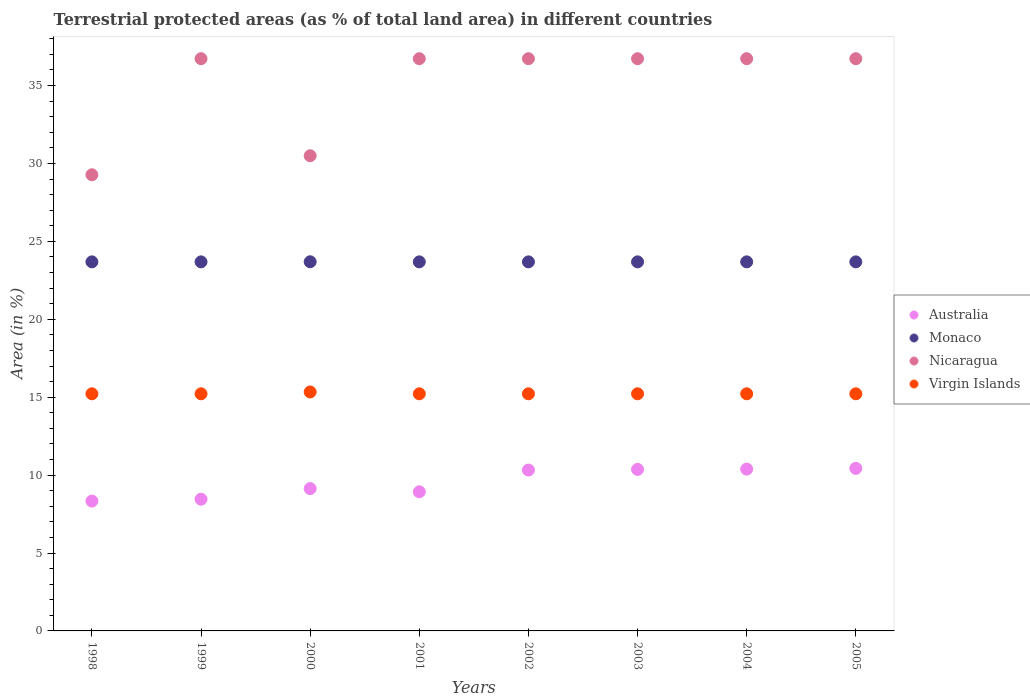Is the number of dotlines equal to the number of legend labels?
Ensure brevity in your answer.  Yes. What is the percentage of terrestrial protected land in Nicaragua in 2002?
Provide a short and direct response. 36.72. Across all years, what is the maximum percentage of terrestrial protected land in Monaco?
Your answer should be compact. 23.69. Across all years, what is the minimum percentage of terrestrial protected land in Monaco?
Give a very brief answer. 23.68. In which year was the percentage of terrestrial protected land in Australia maximum?
Your response must be concise. 2005. In which year was the percentage of terrestrial protected land in Australia minimum?
Make the answer very short. 1998. What is the total percentage of terrestrial protected land in Virgin Islands in the graph?
Ensure brevity in your answer.  121.86. What is the difference between the percentage of terrestrial protected land in Nicaragua in 1999 and the percentage of terrestrial protected land in Australia in 2000?
Your answer should be very brief. 27.59. What is the average percentage of terrestrial protected land in Monaco per year?
Make the answer very short. 23.69. In the year 1999, what is the difference between the percentage of terrestrial protected land in Australia and percentage of terrestrial protected land in Monaco?
Offer a terse response. -15.23. Is the difference between the percentage of terrestrial protected land in Australia in 2000 and 2003 greater than the difference between the percentage of terrestrial protected land in Monaco in 2000 and 2003?
Make the answer very short. No. What is the difference between the highest and the second highest percentage of terrestrial protected land in Monaco?
Your response must be concise. 0.01. What is the difference between the highest and the lowest percentage of terrestrial protected land in Virgin Islands?
Offer a terse response. 0.12. Is the sum of the percentage of terrestrial protected land in Nicaragua in 2002 and 2005 greater than the maximum percentage of terrestrial protected land in Monaco across all years?
Keep it short and to the point. Yes. Is it the case that in every year, the sum of the percentage of terrestrial protected land in Monaco and percentage of terrestrial protected land in Nicaragua  is greater than the percentage of terrestrial protected land in Australia?
Offer a very short reply. Yes. Is the percentage of terrestrial protected land in Monaco strictly greater than the percentage of terrestrial protected land in Virgin Islands over the years?
Make the answer very short. Yes. How many dotlines are there?
Provide a succinct answer. 4. How many years are there in the graph?
Provide a short and direct response. 8. What is the difference between two consecutive major ticks on the Y-axis?
Your answer should be compact. 5. Are the values on the major ticks of Y-axis written in scientific E-notation?
Your response must be concise. No. Does the graph contain any zero values?
Offer a very short reply. No. Where does the legend appear in the graph?
Give a very brief answer. Center right. How many legend labels are there?
Ensure brevity in your answer.  4. How are the legend labels stacked?
Ensure brevity in your answer.  Vertical. What is the title of the graph?
Provide a succinct answer. Terrestrial protected areas (as % of total land area) in different countries. Does "Congo (Republic)" appear as one of the legend labels in the graph?
Ensure brevity in your answer.  No. What is the label or title of the X-axis?
Provide a succinct answer. Years. What is the label or title of the Y-axis?
Offer a very short reply. Area (in %). What is the Area (in %) of Australia in 1998?
Keep it short and to the point. 8.33. What is the Area (in %) of Monaco in 1998?
Provide a succinct answer. 23.68. What is the Area (in %) in Nicaragua in 1998?
Your response must be concise. 29.27. What is the Area (in %) of Virgin Islands in 1998?
Provide a succinct answer. 15.22. What is the Area (in %) in Australia in 1999?
Ensure brevity in your answer.  8.45. What is the Area (in %) in Monaco in 1999?
Give a very brief answer. 23.68. What is the Area (in %) of Nicaragua in 1999?
Provide a succinct answer. 36.72. What is the Area (in %) of Virgin Islands in 1999?
Provide a short and direct response. 15.22. What is the Area (in %) in Australia in 2000?
Offer a terse response. 9.13. What is the Area (in %) in Monaco in 2000?
Provide a succinct answer. 23.69. What is the Area (in %) of Nicaragua in 2000?
Keep it short and to the point. 30.49. What is the Area (in %) of Virgin Islands in 2000?
Make the answer very short. 15.34. What is the Area (in %) of Australia in 2001?
Your answer should be compact. 8.93. What is the Area (in %) of Monaco in 2001?
Give a very brief answer. 23.68. What is the Area (in %) of Nicaragua in 2001?
Keep it short and to the point. 36.72. What is the Area (in %) of Virgin Islands in 2001?
Ensure brevity in your answer.  15.22. What is the Area (in %) of Australia in 2002?
Provide a succinct answer. 10.32. What is the Area (in %) of Monaco in 2002?
Provide a short and direct response. 23.68. What is the Area (in %) of Nicaragua in 2002?
Offer a terse response. 36.72. What is the Area (in %) of Virgin Islands in 2002?
Your response must be concise. 15.22. What is the Area (in %) of Australia in 2003?
Offer a terse response. 10.37. What is the Area (in %) in Monaco in 2003?
Make the answer very short. 23.68. What is the Area (in %) of Nicaragua in 2003?
Provide a short and direct response. 36.72. What is the Area (in %) in Virgin Islands in 2003?
Offer a terse response. 15.22. What is the Area (in %) of Australia in 2004?
Make the answer very short. 10.39. What is the Area (in %) in Monaco in 2004?
Offer a terse response. 23.68. What is the Area (in %) of Nicaragua in 2004?
Offer a very short reply. 36.72. What is the Area (in %) of Virgin Islands in 2004?
Offer a very short reply. 15.22. What is the Area (in %) of Australia in 2005?
Offer a very short reply. 10.43. What is the Area (in %) in Monaco in 2005?
Offer a very short reply. 23.68. What is the Area (in %) in Nicaragua in 2005?
Offer a very short reply. 36.72. What is the Area (in %) of Virgin Islands in 2005?
Provide a succinct answer. 15.22. Across all years, what is the maximum Area (in %) of Australia?
Ensure brevity in your answer.  10.43. Across all years, what is the maximum Area (in %) of Monaco?
Your response must be concise. 23.69. Across all years, what is the maximum Area (in %) of Nicaragua?
Offer a very short reply. 36.72. Across all years, what is the maximum Area (in %) of Virgin Islands?
Make the answer very short. 15.34. Across all years, what is the minimum Area (in %) in Australia?
Give a very brief answer. 8.33. Across all years, what is the minimum Area (in %) of Monaco?
Provide a short and direct response. 23.68. Across all years, what is the minimum Area (in %) of Nicaragua?
Make the answer very short. 29.27. Across all years, what is the minimum Area (in %) in Virgin Islands?
Your answer should be compact. 15.22. What is the total Area (in %) of Australia in the graph?
Offer a very short reply. 76.36. What is the total Area (in %) of Monaco in the graph?
Your answer should be very brief. 189.48. What is the total Area (in %) of Nicaragua in the graph?
Make the answer very short. 280.11. What is the total Area (in %) in Virgin Islands in the graph?
Your response must be concise. 121.86. What is the difference between the Area (in %) of Australia in 1998 and that in 1999?
Give a very brief answer. -0.12. What is the difference between the Area (in %) of Nicaragua in 1998 and that in 1999?
Provide a short and direct response. -7.45. What is the difference between the Area (in %) in Australia in 1998 and that in 2000?
Give a very brief answer. -0.8. What is the difference between the Area (in %) of Monaco in 1998 and that in 2000?
Provide a succinct answer. -0.01. What is the difference between the Area (in %) in Nicaragua in 1998 and that in 2000?
Your answer should be very brief. -1.22. What is the difference between the Area (in %) of Virgin Islands in 1998 and that in 2000?
Ensure brevity in your answer.  -0.12. What is the difference between the Area (in %) of Australia in 1998 and that in 2001?
Provide a succinct answer. -0.59. What is the difference between the Area (in %) of Nicaragua in 1998 and that in 2001?
Your answer should be compact. -7.45. What is the difference between the Area (in %) of Virgin Islands in 1998 and that in 2001?
Your answer should be compact. 0. What is the difference between the Area (in %) in Australia in 1998 and that in 2002?
Your answer should be very brief. -1.99. What is the difference between the Area (in %) of Nicaragua in 1998 and that in 2002?
Provide a succinct answer. -7.45. What is the difference between the Area (in %) of Australia in 1998 and that in 2003?
Offer a terse response. -2.03. What is the difference between the Area (in %) of Monaco in 1998 and that in 2003?
Provide a short and direct response. 0. What is the difference between the Area (in %) in Nicaragua in 1998 and that in 2003?
Keep it short and to the point. -7.45. What is the difference between the Area (in %) in Australia in 1998 and that in 2004?
Provide a short and direct response. -2.05. What is the difference between the Area (in %) of Nicaragua in 1998 and that in 2004?
Offer a terse response. -7.45. What is the difference between the Area (in %) in Australia in 1998 and that in 2005?
Offer a terse response. -2.1. What is the difference between the Area (in %) in Monaco in 1998 and that in 2005?
Your answer should be very brief. 0. What is the difference between the Area (in %) of Nicaragua in 1998 and that in 2005?
Offer a very short reply. -7.45. What is the difference between the Area (in %) in Australia in 1999 and that in 2000?
Give a very brief answer. -0.68. What is the difference between the Area (in %) of Monaco in 1999 and that in 2000?
Provide a succinct answer. -0.01. What is the difference between the Area (in %) of Nicaragua in 1999 and that in 2000?
Your answer should be compact. 6.23. What is the difference between the Area (in %) of Virgin Islands in 1999 and that in 2000?
Your answer should be very brief. -0.12. What is the difference between the Area (in %) in Australia in 1999 and that in 2001?
Your answer should be very brief. -0.48. What is the difference between the Area (in %) in Monaco in 1999 and that in 2001?
Make the answer very short. 0. What is the difference between the Area (in %) in Nicaragua in 1999 and that in 2001?
Offer a very short reply. 0. What is the difference between the Area (in %) in Australia in 1999 and that in 2002?
Give a very brief answer. -1.87. What is the difference between the Area (in %) in Monaco in 1999 and that in 2002?
Your answer should be compact. 0. What is the difference between the Area (in %) of Virgin Islands in 1999 and that in 2002?
Make the answer very short. 0. What is the difference between the Area (in %) of Australia in 1999 and that in 2003?
Your response must be concise. -1.91. What is the difference between the Area (in %) of Virgin Islands in 1999 and that in 2003?
Make the answer very short. 0. What is the difference between the Area (in %) of Australia in 1999 and that in 2004?
Ensure brevity in your answer.  -1.93. What is the difference between the Area (in %) of Nicaragua in 1999 and that in 2004?
Your response must be concise. 0. What is the difference between the Area (in %) of Australia in 1999 and that in 2005?
Provide a short and direct response. -1.98. What is the difference between the Area (in %) in Monaco in 1999 and that in 2005?
Your answer should be compact. 0. What is the difference between the Area (in %) in Virgin Islands in 1999 and that in 2005?
Your response must be concise. 0. What is the difference between the Area (in %) in Australia in 2000 and that in 2001?
Offer a terse response. 0.21. What is the difference between the Area (in %) of Monaco in 2000 and that in 2001?
Provide a succinct answer. 0.01. What is the difference between the Area (in %) in Nicaragua in 2000 and that in 2001?
Provide a short and direct response. -6.23. What is the difference between the Area (in %) in Virgin Islands in 2000 and that in 2001?
Keep it short and to the point. 0.12. What is the difference between the Area (in %) of Australia in 2000 and that in 2002?
Keep it short and to the point. -1.19. What is the difference between the Area (in %) in Monaco in 2000 and that in 2002?
Your answer should be very brief. 0.01. What is the difference between the Area (in %) in Nicaragua in 2000 and that in 2002?
Keep it short and to the point. -6.23. What is the difference between the Area (in %) of Virgin Islands in 2000 and that in 2002?
Provide a succinct answer. 0.12. What is the difference between the Area (in %) in Australia in 2000 and that in 2003?
Your answer should be compact. -1.23. What is the difference between the Area (in %) of Monaco in 2000 and that in 2003?
Provide a short and direct response. 0.01. What is the difference between the Area (in %) in Nicaragua in 2000 and that in 2003?
Give a very brief answer. -6.23. What is the difference between the Area (in %) of Virgin Islands in 2000 and that in 2003?
Give a very brief answer. 0.12. What is the difference between the Area (in %) in Australia in 2000 and that in 2004?
Give a very brief answer. -1.25. What is the difference between the Area (in %) in Monaco in 2000 and that in 2004?
Offer a terse response. 0.01. What is the difference between the Area (in %) in Nicaragua in 2000 and that in 2004?
Your response must be concise. -6.23. What is the difference between the Area (in %) in Virgin Islands in 2000 and that in 2004?
Your answer should be compact. 0.12. What is the difference between the Area (in %) of Australia in 2000 and that in 2005?
Your answer should be very brief. -1.3. What is the difference between the Area (in %) of Monaco in 2000 and that in 2005?
Ensure brevity in your answer.  0.01. What is the difference between the Area (in %) in Nicaragua in 2000 and that in 2005?
Ensure brevity in your answer.  -6.23. What is the difference between the Area (in %) of Virgin Islands in 2000 and that in 2005?
Give a very brief answer. 0.12. What is the difference between the Area (in %) in Australia in 2001 and that in 2002?
Keep it short and to the point. -1.4. What is the difference between the Area (in %) of Monaco in 2001 and that in 2002?
Make the answer very short. 0. What is the difference between the Area (in %) of Nicaragua in 2001 and that in 2002?
Make the answer very short. 0. What is the difference between the Area (in %) of Australia in 2001 and that in 2003?
Give a very brief answer. -1.44. What is the difference between the Area (in %) of Monaco in 2001 and that in 2003?
Offer a very short reply. 0. What is the difference between the Area (in %) of Virgin Islands in 2001 and that in 2003?
Your answer should be compact. 0. What is the difference between the Area (in %) of Australia in 2001 and that in 2004?
Your answer should be compact. -1.46. What is the difference between the Area (in %) of Monaco in 2001 and that in 2004?
Your answer should be compact. 0. What is the difference between the Area (in %) in Nicaragua in 2001 and that in 2004?
Provide a short and direct response. 0. What is the difference between the Area (in %) of Australia in 2001 and that in 2005?
Provide a succinct answer. -1.5. What is the difference between the Area (in %) of Australia in 2002 and that in 2003?
Provide a short and direct response. -0.04. What is the difference between the Area (in %) in Nicaragua in 2002 and that in 2003?
Offer a terse response. 0. What is the difference between the Area (in %) in Australia in 2002 and that in 2004?
Keep it short and to the point. -0.06. What is the difference between the Area (in %) in Australia in 2002 and that in 2005?
Your answer should be compact. -0.11. What is the difference between the Area (in %) in Australia in 2003 and that in 2004?
Your response must be concise. -0.02. What is the difference between the Area (in %) of Monaco in 2003 and that in 2004?
Your answer should be compact. 0. What is the difference between the Area (in %) in Nicaragua in 2003 and that in 2004?
Give a very brief answer. 0. What is the difference between the Area (in %) in Australia in 2003 and that in 2005?
Ensure brevity in your answer.  -0.07. What is the difference between the Area (in %) of Monaco in 2003 and that in 2005?
Ensure brevity in your answer.  0. What is the difference between the Area (in %) of Nicaragua in 2003 and that in 2005?
Make the answer very short. 0. What is the difference between the Area (in %) of Virgin Islands in 2003 and that in 2005?
Make the answer very short. 0. What is the difference between the Area (in %) of Australia in 2004 and that in 2005?
Ensure brevity in your answer.  -0.05. What is the difference between the Area (in %) in Monaco in 2004 and that in 2005?
Your answer should be very brief. 0. What is the difference between the Area (in %) of Virgin Islands in 2004 and that in 2005?
Offer a terse response. 0. What is the difference between the Area (in %) in Australia in 1998 and the Area (in %) in Monaco in 1999?
Your answer should be very brief. -15.35. What is the difference between the Area (in %) of Australia in 1998 and the Area (in %) of Nicaragua in 1999?
Provide a succinct answer. -28.39. What is the difference between the Area (in %) of Australia in 1998 and the Area (in %) of Virgin Islands in 1999?
Ensure brevity in your answer.  -6.88. What is the difference between the Area (in %) of Monaco in 1998 and the Area (in %) of Nicaragua in 1999?
Your response must be concise. -13.04. What is the difference between the Area (in %) of Monaco in 1998 and the Area (in %) of Virgin Islands in 1999?
Provide a short and direct response. 8.47. What is the difference between the Area (in %) of Nicaragua in 1998 and the Area (in %) of Virgin Islands in 1999?
Provide a succinct answer. 14.06. What is the difference between the Area (in %) in Australia in 1998 and the Area (in %) in Monaco in 2000?
Offer a very short reply. -15.36. What is the difference between the Area (in %) of Australia in 1998 and the Area (in %) of Nicaragua in 2000?
Make the answer very short. -22.16. What is the difference between the Area (in %) in Australia in 1998 and the Area (in %) in Virgin Islands in 2000?
Your response must be concise. -7. What is the difference between the Area (in %) in Monaco in 1998 and the Area (in %) in Nicaragua in 2000?
Your answer should be compact. -6.81. What is the difference between the Area (in %) in Monaco in 1998 and the Area (in %) in Virgin Islands in 2000?
Your answer should be very brief. 8.35. What is the difference between the Area (in %) in Nicaragua in 1998 and the Area (in %) in Virgin Islands in 2000?
Provide a short and direct response. 13.94. What is the difference between the Area (in %) of Australia in 1998 and the Area (in %) of Monaco in 2001?
Ensure brevity in your answer.  -15.35. What is the difference between the Area (in %) of Australia in 1998 and the Area (in %) of Nicaragua in 2001?
Ensure brevity in your answer.  -28.39. What is the difference between the Area (in %) in Australia in 1998 and the Area (in %) in Virgin Islands in 2001?
Provide a short and direct response. -6.88. What is the difference between the Area (in %) of Monaco in 1998 and the Area (in %) of Nicaragua in 2001?
Provide a short and direct response. -13.04. What is the difference between the Area (in %) in Monaco in 1998 and the Area (in %) in Virgin Islands in 2001?
Provide a short and direct response. 8.47. What is the difference between the Area (in %) of Nicaragua in 1998 and the Area (in %) of Virgin Islands in 2001?
Your response must be concise. 14.06. What is the difference between the Area (in %) in Australia in 1998 and the Area (in %) in Monaco in 2002?
Provide a succinct answer. -15.35. What is the difference between the Area (in %) of Australia in 1998 and the Area (in %) of Nicaragua in 2002?
Provide a short and direct response. -28.39. What is the difference between the Area (in %) of Australia in 1998 and the Area (in %) of Virgin Islands in 2002?
Ensure brevity in your answer.  -6.88. What is the difference between the Area (in %) of Monaco in 1998 and the Area (in %) of Nicaragua in 2002?
Offer a terse response. -13.04. What is the difference between the Area (in %) in Monaco in 1998 and the Area (in %) in Virgin Islands in 2002?
Offer a terse response. 8.47. What is the difference between the Area (in %) in Nicaragua in 1998 and the Area (in %) in Virgin Islands in 2002?
Your answer should be very brief. 14.06. What is the difference between the Area (in %) of Australia in 1998 and the Area (in %) of Monaco in 2003?
Offer a terse response. -15.35. What is the difference between the Area (in %) in Australia in 1998 and the Area (in %) in Nicaragua in 2003?
Your response must be concise. -28.39. What is the difference between the Area (in %) of Australia in 1998 and the Area (in %) of Virgin Islands in 2003?
Your answer should be compact. -6.88. What is the difference between the Area (in %) in Monaco in 1998 and the Area (in %) in Nicaragua in 2003?
Provide a short and direct response. -13.04. What is the difference between the Area (in %) of Monaco in 1998 and the Area (in %) of Virgin Islands in 2003?
Offer a terse response. 8.47. What is the difference between the Area (in %) in Nicaragua in 1998 and the Area (in %) in Virgin Islands in 2003?
Give a very brief answer. 14.06. What is the difference between the Area (in %) in Australia in 1998 and the Area (in %) in Monaco in 2004?
Ensure brevity in your answer.  -15.35. What is the difference between the Area (in %) of Australia in 1998 and the Area (in %) of Nicaragua in 2004?
Provide a succinct answer. -28.39. What is the difference between the Area (in %) in Australia in 1998 and the Area (in %) in Virgin Islands in 2004?
Keep it short and to the point. -6.88. What is the difference between the Area (in %) of Monaco in 1998 and the Area (in %) of Nicaragua in 2004?
Provide a short and direct response. -13.04. What is the difference between the Area (in %) in Monaco in 1998 and the Area (in %) in Virgin Islands in 2004?
Your response must be concise. 8.47. What is the difference between the Area (in %) in Nicaragua in 1998 and the Area (in %) in Virgin Islands in 2004?
Offer a terse response. 14.06. What is the difference between the Area (in %) in Australia in 1998 and the Area (in %) in Monaco in 2005?
Offer a terse response. -15.35. What is the difference between the Area (in %) of Australia in 1998 and the Area (in %) of Nicaragua in 2005?
Offer a terse response. -28.39. What is the difference between the Area (in %) in Australia in 1998 and the Area (in %) in Virgin Islands in 2005?
Your answer should be very brief. -6.88. What is the difference between the Area (in %) of Monaco in 1998 and the Area (in %) of Nicaragua in 2005?
Ensure brevity in your answer.  -13.04. What is the difference between the Area (in %) of Monaco in 1998 and the Area (in %) of Virgin Islands in 2005?
Provide a succinct answer. 8.47. What is the difference between the Area (in %) of Nicaragua in 1998 and the Area (in %) of Virgin Islands in 2005?
Provide a succinct answer. 14.06. What is the difference between the Area (in %) in Australia in 1999 and the Area (in %) in Monaco in 2000?
Ensure brevity in your answer.  -15.24. What is the difference between the Area (in %) in Australia in 1999 and the Area (in %) in Nicaragua in 2000?
Keep it short and to the point. -22.04. What is the difference between the Area (in %) in Australia in 1999 and the Area (in %) in Virgin Islands in 2000?
Provide a succinct answer. -6.88. What is the difference between the Area (in %) in Monaco in 1999 and the Area (in %) in Nicaragua in 2000?
Your response must be concise. -6.81. What is the difference between the Area (in %) in Monaco in 1999 and the Area (in %) in Virgin Islands in 2000?
Provide a short and direct response. 8.35. What is the difference between the Area (in %) in Nicaragua in 1999 and the Area (in %) in Virgin Islands in 2000?
Make the answer very short. 21.39. What is the difference between the Area (in %) of Australia in 1999 and the Area (in %) of Monaco in 2001?
Your answer should be very brief. -15.23. What is the difference between the Area (in %) in Australia in 1999 and the Area (in %) in Nicaragua in 2001?
Offer a terse response. -28.27. What is the difference between the Area (in %) of Australia in 1999 and the Area (in %) of Virgin Islands in 2001?
Provide a short and direct response. -6.76. What is the difference between the Area (in %) in Monaco in 1999 and the Area (in %) in Nicaragua in 2001?
Keep it short and to the point. -13.04. What is the difference between the Area (in %) in Monaco in 1999 and the Area (in %) in Virgin Islands in 2001?
Ensure brevity in your answer.  8.47. What is the difference between the Area (in %) in Nicaragua in 1999 and the Area (in %) in Virgin Islands in 2001?
Make the answer very short. 21.51. What is the difference between the Area (in %) of Australia in 1999 and the Area (in %) of Monaco in 2002?
Your response must be concise. -15.23. What is the difference between the Area (in %) of Australia in 1999 and the Area (in %) of Nicaragua in 2002?
Ensure brevity in your answer.  -28.27. What is the difference between the Area (in %) in Australia in 1999 and the Area (in %) in Virgin Islands in 2002?
Provide a short and direct response. -6.76. What is the difference between the Area (in %) in Monaco in 1999 and the Area (in %) in Nicaragua in 2002?
Provide a succinct answer. -13.04. What is the difference between the Area (in %) of Monaco in 1999 and the Area (in %) of Virgin Islands in 2002?
Offer a very short reply. 8.47. What is the difference between the Area (in %) in Nicaragua in 1999 and the Area (in %) in Virgin Islands in 2002?
Keep it short and to the point. 21.51. What is the difference between the Area (in %) in Australia in 1999 and the Area (in %) in Monaco in 2003?
Offer a very short reply. -15.23. What is the difference between the Area (in %) in Australia in 1999 and the Area (in %) in Nicaragua in 2003?
Offer a terse response. -28.27. What is the difference between the Area (in %) of Australia in 1999 and the Area (in %) of Virgin Islands in 2003?
Your response must be concise. -6.76. What is the difference between the Area (in %) in Monaco in 1999 and the Area (in %) in Nicaragua in 2003?
Provide a short and direct response. -13.04. What is the difference between the Area (in %) of Monaco in 1999 and the Area (in %) of Virgin Islands in 2003?
Provide a succinct answer. 8.47. What is the difference between the Area (in %) of Nicaragua in 1999 and the Area (in %) of Virgin Islands in 2003?
Make the answer very short. 21.51. What is the difference between the Area (in %) of Australia in 1999 and the Area (in %) of Monaco in 2004?
Provide a succinct answer. -15.23. What is the difference between the Area (in %) in Australia in 1999 and the Area (in %) in Nicaragua in 2004?
Your answer should be very brief. -28.27. What is the difference between the Area (in %) of Australia in 1999 and the Area (in %) of Virgin Islands in 2004?
Give a very brief answer. -6.76. What is the difference between the Area (in %) of Monaco in 1999 and the Area (in %) of Nicaragua in 2004?
Keep it short and to the point. -13.04. What is the difference between the Area (in %) in Monaco in 1999 and the Area (in %) in Virgin Islands in 2004?
Give a very brief answer. 8.47. What is the difference between the Area (in %) in Nicaragua in 1999 and the Area (in %) in Virgin Islands in 2004?
Your answer should be very brief. 21.51. What is the difference between the Area (in %) in Australia in 1999 and the Area (in %) in Monaco in 2005?
Your answer should be compact. -15.23. What is the difference between the Area (in %) in Australia in 1999 and the Area (in %) in Nicaragua in 2005?
Your answer should be compact. -28.27. What is the difference between the Area (in %) of Australia in 1999 and the Area (in %) of Virgin Islands in 2005?
Your answer should be compact. -6.76. What is the difference between the Area (in %) of Monaco in 1999 and the Area (in %) of Nicaragua in 2005?
Offer a terse response. -13.04. What is the difference between the Area (in %) in Monaco in 1999 and the Area (in %) in Virgin Islands in 2005?
Provide a succinct answer. 8.47. What is the difference between the Area (in %) of Nicaragua in 1999 and the Area (in %) of Virgin Islands in 2005?
Your answer should be compact. 21.51. What is the difference between the Area (in %) in Australia in 2000 and the Area (in %) in Monaco in 2001?
Keep it short and to the point. -14.55. What is the difference between the Area (in %) of Australia in 2000 and the Area (in %) of Nicaragua in 2001?
Provide a succinct answer. -27.59. What is the difference between the Area (in %) in Australia in 2000 and the Area (in %) in Virgin Islands in 2001?
Ensure brevity in your answer.  -6.08. What is the difference between the Area (in %) of Monaco in 2000 and the Area (in %) of Nicaragua in 2001?
Offer a terse response. -13.03. What is the difference between the Area (in %) of Monaco in 2000 and the Area (in %) of Virgin Islands in 2001?
Ensure brevity in your answer.  8.47. What is the difference between the Area (in %) in Nicaragua in 2000 and the Area (in %) in Virgin Islands in 2001?
Give a very brief answer. 15.28. What is the difference between the Area (in %) in Australia in 2000 and the Area (in %) in Monaco in 2002?
Provide a short and direct response. -14.55. What is the difference between the Area (in %) in Australia in 2000 and the Area (in %) in Nicaragua in 2002?
Ensure brevity in your answer.  -27.59. What is the difference between the Area (in %) in Australia in 2000 and the Area (in %) in Virgin Islands in 2002?
Your answer should be very brief. -6.08. What is the difference between the Area (in %) in Monaco in 2000 and the Area (in %) in Nicaragua in 2002?
Provide a succinct answer. -13.03. What is the difference between the Area (in %) of Monaco in 2000 and the Area (in %) of Virgin Islands in 2002?
Keep it short and to the point. 8.47. What is the difference between the Area (in %) in Nicaragua in 2000 and the Area (in %) in Virgin Islands in 2002?
Your response must be concise. 15.28. What is the difference between the Area (in %) in Australia in 2000 and the Area (in %) in Monaco in 2003?
Keep it short and to the point. -14.55. What is the difference between the Area (in %) of Australia in 2000 and the Area (in %) of Nicaragua in 2003?
Offer a terse response. -27.59. What is the difference between the Area (in %) in Australia in 2000 and the Area (in %) in Virgin Islands in 2003?
Ensure brevity in your answer.  -6.08. What is the difference between the Area (in %) in Monaco in 2000 and the Area (in %) in Nicaragua in 2003?
Give a very brief answer. -13.03. What is the difference between the Area (in %) of Monaco in 2000 and the Area (in %) of Virgin Islands in 2003?
Your answer should be compact. 8.47. What is the difference between the Area (in %) in Nicaragua in 2000 and the Area (in %) in Virgin Islands in 2003?
Provide a succinct answer. 15.28. What is the difference between the Area (in %) of Australia in 2000 and the Area (in %) of Monaco in 2004?
Your answer should be compact. -14.55. What is the difference between the Area (in %) of Australia in 2000 and the Area (in %) of Nicaragua in 2004?
Make the answer very short. -27.59. What is the difference between the Area (in %) in Australia in 2000 and the Area (in %) in Virgin Islands in 2004?
Offer a very short reply. -6.08. What is the difference between the Area (in %) in Monaco in 2000 and the Area (in %) in Nicaragua in 2004?
Provide a succinct answer. -13.03. What is the difference between the Area (in %) in Monaco in 2000 and the Area (in %) in Virgin Islands in 2004?
Give a very brief answer. 8.47. What is the difference between the Area (in %) in Nicaragua in 2000 and the Area (in %) in Virgin Islands in 2004?
Provide a succinct answer. 15.28. What is the difference between the Area (in %) in Australia in 2000 and the Area (in %) in Monaco in 2005?
Your answer should be very brief. -14.55. What is the difference between the Area (in %) in Australia in 2000 and the Area (in %) in Nicaragua in 2005?
Offer a very short reply. -27.59. What is the difference between the Area (in %) in Australia in 2000 and the Area (in %) in Virgin Islands in 2005?
Provide a short and direct response. -6.08. What is the difference between the Area (in %) in Monaco in 2000 and the Area (in %) in Nicaragua in 2005?
Offer a very short reply. -13.03. What is the difference between the Area (in %) in Monaco in 2000 and the Area (in %) in Virgin Islands in 2005?
Your answer should be compact. 8.47. What is the difference between the Area (in %) of Nicaragua in 2000 and the Area (in %) of Virgin Islands in 2005?
Provide a short and direct response. 15.28. What is the difference between the Area (in %) of Australia in 2001 and the Area (in %) of Monaco in 2002?
Make the answer very short. -14.76. What is the difference between the Area (in %) of Australia in 2001 and the Area (in %) of Nicaragua in 2002?
Your answer should be compact. -27.79. What is the difference between the Area (in %) in Australia in 2001 and the Area (in %) in Virgin Islands in 2002?
Offer a terse response. -6.29. What is the difference between the Area (in %) of Monaco in 2001 and the Area (in %) of Nicaragua in 2002?
Your answer should be compact. -13.04. What is the difference between the Area (in %) of Monaco in 2001 and the Area (in %) of Virgin Islands in 2002?
Keep it short and to the point. 8.47. What is the difference between the Area (in %) in Nicaragua in 2001 and the Area (in %) in Virgin Islands in 2002?
Your answer should be compact. 21.51. What is the difference between the Area (in %) of Australia in 2001 and the Area (in %) of Monaco in 2003?
Your response must be concise. -14.76. What is the difference between the Area (in %) of Australia in 2001 and the Area (in %) of Nicaragua in 2003?
Ensure brevity in your answer.  -27.79. What is the difference between the Area (in %) of Australia in 2001 and the Area (in %) of Virgin Islands in 2003?
Ensure brevity in your answer.  -6.29. What is the difference between the Area (in %) of Monaco in 2001 and the Area (in %) of Nicaragua in 2003?
Offer a very short reply. -13.04. What is the difference between the Area (in %) in Monaco in 2001 and the Area (in %) in Virgin Islands in 2003?
Provide a short and direct response. 8.47. What is the difference between the Area (in %) of Nicaragua in 2001 and the Area (in %) of Virgin Islands in 2003?
Provide a short and direct response. 21.51. What is the difference between the Area (in %) of Australia in 2001 and the Area (in %) of Monaco in 2004?
Ensure brevity in your answer.  -14.76. What is the difference between the Area (in %) in Australia in 2001 and the Area (in %) in Nicaragua in 2004?
Ensure brevity in your answer.  -27.79. What is the difference between the Area (in %) of Australia in 2001 and the Area (in %) of Virgin Islands in 2004?
Your response must be concise. -6.29. What is the difference between the Area (in %) in Monaco in 2001 and the Area (in %) in Nicaragua in 2004?
Provide a succinct answer. -13.04. What is the difference between the Area (in %) of Monaco in 2001 and the Area (in %) of Virgin Islands in 2004?
Make the answer very short. 8.47. What is the difference between the Area (in %) in Nicaragua in 2001 and the Area (in %) in Virgin Islands in 2004?
Keep it short and to the point. 21.51. What is the difference between the Area (in %) of Australia in 2001 and the Area (in %) of Monaco in 2005?
Make the answer very short. -14.76. What is the difference between the Area (in %) in Australia in 2001 and the Area (in %) in Nicaragua in 2005?
Ensure brevity in your answer.  -27.79. What is the difference between the Area (in %) in Australia in 2001 and the Area (in %) in Virgin Islands in 2005?
Give a very brief answer. -6.29. What is the difference between the Area (in %) of Monaco in 2001 and the Area (in %) of Nicaragua in 2005?
Offer a terse response. -13.04. What is the difference between the Area (in %) in Monaco in 2001 and the Area (in %) in Virgin Islands in 2005?
Offer a very short reply. 8.47. What is the difference between the Area (in %) of Nicaragua in 2001 and the Area (in %) of Virgin Islands in 2005?
Give a very brief answer. 21.51. What is the difference between the Area (in %) of Australia in 2002 and the Area (in %) of Monaco in 2003?
Your answer should be compact. -13.36. What is the difference between the Area (in %) of Australia in 2002 and the Area (in %) of Nicaragua in 2003?
Your answer should be very brief. -26.4. What is the difference between the Area (in %) of Australia in 2002 and the Area (in %) of Virgin Islands in 2003?
Offer a terse response. -4.89. What is the difference between the Area (in %) in Monaco in 2002 and the Area (in %) in Nicaragua in 2003?
Give a very brief answer. -13.04. What is the difference between the Area (in %) in Monaco in 2002 and the Area (in %) in Virgin Islands in 2003?
Your answer should be very brief. 8.47. What is the difference between the Area (in %) in Nicaragua in 2002 and the Area (in %) in Virgin Islands in 2003?
Make the answer very short. 21.51. What is the difference between the Area (in %) in Australia in 2002 and the Area (in %) in Monaco in 2004?
Make the answer very short. -13.36. What is the difference between the Area (in %) of Australia in 2002 and the Area (in %) of Nicaragua in 2004?
Offer a very short reply. -26.4. What is the difference between the Area (in %) of Australia in 2002 and the Area (in %) of Virgin Islands in 2004?
Offer a terse response. -4.89. What is the difference between the Area (in %) of Monaco in 2002 and the Area (in %) of Nicaragua in 2004?
Provide a short and direct response. -13.04. What is the difference between the Area (in %) in Monaco in 2002 and the Area (in %) in Virgin Islands in 2004?
Keep it short and to the point. 8.47. What is the difference between the Area (in %) in Nicaragua in 2002 and the Area (in %) in Virgin Islands in 2004?
Provide a succinct answer. 21.51. What is the difference between the Area (in %) of Australia in 2002 and the Area (in %) of Monaco in 2005?
Keep it short and to the point. -13.36. What is the difference between the Area (in %) of Australia in 2002 and the Area (in %) of Nicaragua in 2005?
Offer a very short reply. -26.4. What is the difference between the Area (in %) of Australia in 2002 and the Area (in %) of Virgin Islands in 2005?
Provide a succinct answer. -4.89. What is the difference between the Area (in %) in Monaco in 2002 and the Area (in %) in Nicaragua in 2005?
Offer a very short reply. -13.04. What is the difference between the Area (in %) in Monaco in 2002 and the Area (in %) in Virgin Islands in 2005?
Your answer should be compact. 8.47. What is the difference between the Area (in %) of Nicaragua in 2002 and the Area (in %) of Virgin Islands in 2005?
Offer a terse response. 21.51. What is the difference between the Area (in %) in Australia in 2003 and the Area (in %) in Monaco in 2004?
Provide a short and direct response. -13.32. What is the difference between the Area (in %) of Australia in 2003 and the Area (in %) of Nicaragua in 2004?
Your response must be concise. -26.36. What is the difference between the Area (in %) in Australia in 2003 and the Area (in %) in Virgin Islands in 2004?
Provide a short and direct response. -4.85. What is the difference between the Area (in %) of Monaco in 2003 and the Area (in %) of Nicaragua in 2004?
Offer a terse response. -13.04. What is the difference between the Area (in %) of Monaco in 2003 and the Area (in %) of Virgin Islands in 2004?
Your answer should be compact. 8.47. What is the difference between the Area (in %) of Nicaragua in 2003 and the Area (in %) of Virgin Islands in 2004?
Your answer should be compact. 21.51. What is the difference between the Area (in %) in Australia in 2003 and the Area (in %) in Monaco in 2005?
Your answer should be compact. -13.32. What is the difference between the Area (in %) of Australia in 2003 and the Area (in %) of Nicaragua in 2005?
Make the answer very short. -26.36. What is the difference between the Area (in %) in Australia in 2003 and the Area (in %) in Virgin Islands in 2005?
Your answer should be very brief. -4.85. What is the difference between the Area (in %) in Monaco in 2003 and the Area (in %) in Nicaragua in 2005?
Offer a terse response. -13.04. What is the difference between the Area (in %) of Monaco in 2003 and the Area (in %) of Virgin Islands in 2005?
Give a very brief answer. 8.47. What is the difference between the Area (in %) of Nicaragua in 2003 and the Area (in %) of Virgin Islands in 2005?
Make the answer very short. 21.51. What is the difference between the Area (in %) of Australia in 2004 and the Area (in %) of Monaco in 2005?
Make the answer very short. -13.3. What is the difference between the Area (in %) of Australia in 2004 and the Area (in %) of Nicaragua in 2005?
Provide a succinct answer. -26.34. What is the difference between the Area (in %) of Australia in 2004 and the Area (in %) of Virgin Islands in 2005?
Keep it short and to the point. -4.83. What is the difference between the Area (in %) in Monaco in 2004 and the Area (in %) in Nicaragua in 2005?
Your answer should be compact. -13.04. What is the difference between the Area (in %) in Monaco in 2004 and the Area (in %) in Virgin Islands in 2005?
Provide a succinct answer. 8.47. What is the difference between the Area (in %) in Nicaragua in 2004 and the Area (in %) in Virgin Islands in 2005?
Keep it short and to the point. 21.51. What is the average Area (in %) in Australia per year?
Provide a succinct answer. 9.54. What is the average Area (in %) of Monaco per year?
Make the answer very short. 23.69. What is the average Area (in %) of Nicaragua per year?
Keep it short and to the point. 35.01. What is the average Area (in %) in Virgin Islands per year?
Provide a succinct answer. 15.23. In the year 1998, what is the difference between the Area (in %) in Australia and Area (in %) in Monaco?
Offer a terse response. -15.35. In the year 1998, what is the difference between the Area (in %) in Australia and Area (in %) in Nicaragua?
Ensure brevity in your answer.  -20.94. In the year 1998, what is the difference between the Area (in %) in Australia and Area (in %) in Virgin Islands?
Your response must be concise. -6.88. In the year 1998, what is the difference between the Area (in %) in Monaco and Area (in %) in Nicaragua?
Provide a short and direct response. -5.59. In the year 1998, what is the difference between the Area (in %) of Monaco and Area (in %) of Virgin Islands?
Offer a terse response. 8.47. In the year 1998, what is the difference between the Area (in %) in Nicaragua and Area (in %) in Virgin Islands?
Your answer should be compact. 14.06. In the year 1999, what is the difference between the Area (in %) of Australia and Area (in %) of Monaco?
Keep it short and to the point. -15.23. In the year 1999, what is the difference between the Area (in %) in Australia and Area (in %) in Nicaragua?
Your answer should be very brief. -28.27. In the year 1999, what is the difference between the Area (in %) of Australia and Area (in %) of Virgin Islands?
Provide a succinct answer. -6.76. In the year 1999, what is the difference between the Area (in %) of Monaco and Area (in %) of Nicaragua?
Provide a short and direct response. -13.04. In the year 1999, what is the difference between the Area (in %) in Monaco and Area (in %) in Virgin Islands?
Offer a very short reply. 8.47. In the year 1999, what is the difference between the Area (in %) of Nicaragua and Area (in %) of Virgin Islands?
Offer a very short reply. 21.51. In the year 2000, what is the difference between the Area (in %) of Australia and Area (in %) of Monaco?
Keep it short and to the point. -14.56. In the year 2000, what is the difference between the Area (in %) in Australia and Area (in %) in Nicaragua?
Make the answer very short. -21.36. In the year 2000, what is the difference between the Area (in %) of Australia and Area (in %) of Virgin Islands?
Your answer should be very brief. -6.2. In the year 2000, what is the difference between the Area (in %) in Monaco and Area (in %) in Nicaragua?
Ensure brevity in your answer.  -6.8. In the year 2000, what is the difference between the Area (in %) of Monaco and Area (in %) of Virgin Islands?
Your response must be concise. 8.36. In the year 2000, what is the difference between the Area (in %) of Nicaragua and Area (in %) of Virgin Islands?
Provide a short and direct response. 15.16. In the year 2001, what is the difference between the Area (in %) in Australia and Area (in %) in Monaco?
Your answer should be very brief. -14.76. In the year 2001, what is the difference between the Area (in %) in Australia and Area (in %) in Nicaragua?
Provide a succinct answer. -27.79. In the year 2001, what is the difference between the Area (in %) in Australia and Area (in %) in Virgin Islands?
Give a very brief answer. -6.29. In the year 2001, what is the difference between the Area (in %) in Monaco and Area (in %) in Nicaragua?
Your answer should be compact. -13.04. In the year 2001, what is the difference between the Area (in %) of Monaco and Area (in %) of Virgin Islands?
Offer a terse response. 8.47. In the year 2001, what is the difference between the Area (in %) of Nicaragua and Area (in %) of Virgin Islands?
Give a very brief answer. 21.51. In the year 2002, what is the difference between the Area (in %) of Australia and Area (in %) of Monaco?
Give a very brief answer. -13.36. In the year 2002, what is the difference between the Area (in %) in Australia and Area (in %) in Nicaragua?
Your answer should be compact. -26.4. In the year 2002, what is the difference between the Area (in %) in Australia and Area (in %) in Virgin Islands?
Offer a very short reply. -4.89. In the year 2002, what is the difference between the Area (in %) of Monaco and Area (in %) of Nicaragua?
Your response must be concise. -13.04. In the year 2002, what is the difference between the Area (in %) of Monaco and Area (in %) of Virgin Islands?
Offer a very short reply. 8.47. In the year 2002, what is the difference between the Area (in %) of Nicaragua and Area (in %) of Virgin Islands?
Offer a very short reply. 21.51. In the year 2003, what is the difference between the Area (in %) of Australia and Area (in %) of Monaco?
Offer a terse response. -13.32. In the year 2003, what is the difference between the Area (in %) of Australia and Area (in %) of Nicaragua?
Provide a short and direct response. -26.36. In the year 2003, what is the difference between the Area (in %) in Australia and Area (in %) in Virgin Islands?
Offer a very short reply. -4.85. In the year 2003, what is the difference between the Area (in %) in Monaco and Area (in %) in Nicaragua?
Your answer should be very brief. -13.04. In the year 2003, what is the difference between the Area (in %) of Monaco and Area (in %) of Virgin Islands?
Give a very brief answer. 8.47. In the year 2003, what is the difference between the Area (in %) of Nicaragua and Area (in %) of Virgin Islands?
Offer a very short reply. 21.51. In the year 2004, what is the difference between the Area (in %) in Australia and Area (in %) in Monaco?
Offer a terse response. -13.3. In the year 2004, what is the difference between the Area (in %) of Australia and Area (in %) of Nicaragua?
Your answer should be very brief. -26.34. In the year 2004, what is the difference between the Area (in %) in Australia and Area (in %) in Virgin Islands?
Provide a short and direct response. -4.83. In the year 2004, what is the difference between the Area (in %) in Monaco and Area (in %) in Nicaragua?
Provide a short and direct response. -13.04. In the year 2004, what is the difference between the Area (in %) in Monaco and Area (in %) in Virgin Islands?
Give a very brief answer. 8.47. In the year 2004, what is the difference between the Area (in %) in Nicaragua and Area (in %) in Virgin Islands?
Keep it short and to the point. 21.51. In the year 2005, what is the difference between the Area (in %) of Australia and Area (in %) of Monaco?
Keep it short and to the point. -13.25. In the year 2005, what is the difference between the Area (in %) in Australia and Area (in %) in Nicaragua?
Offer a very short reply. -26.29. In the year 2005, what is the difference between the Area (in %) in Australia and Area (in %) in Virgin Islands?
Keep it short and to the point. -4.78. In the year 2005, what is the difference between the Area (in %) of Monaco and Area (in %) of Nicaragua?
Give a very brief answer. -13.04. In the year 2005, what is the difference between the Area (in %) in Monaco and Area (in %) in Virgin Islands?
Your response must be concise. 8.47. In the year 2005, what is the difference between the Area (in %) in Nicaragua and Area (in %) in Virgin Islands?
Make the answer very short. 21.51. What is the ratio of the Area (in %) of Australia in 1998 to that in 1999?
Offer a terse response. 0.99. What is the ratio of the Area (in %) of Nicaragua in 1998 to that in 1999?
Your answer should be compact. 0.8. What is the ratio of the Area (in %) in Australia in 1998 to that in 2000?
Ensure brevity in your answer.  0.91. What is the ratio of the Area (in %) of Monaco in 1998 to that in 2000?
Give a very brief answer. 1. What is the ratio of the Area (in %) in Virgin Islands in 1998 to that in 2000?
Your answer should be very brief. 0.99. What is the ratio of the Area (in %) of Australia in 1998 to that in 2001?
Your response must be concise. 0.93. What is the ratio of the Area (in %) in Monaco in 1998 to that in 2001?
Your answer should be very brief. 1. What is the ratio of the Area (in %) of Nicaragua in 1998 to that in 2001?
Your response must be concise. 0.8. What is the ratio of the Area (in %) of Australia in 1998 to that in 2002?
Provide a short and direct response. 0.81. What is the ratio of the Area (in %) in Monaco in 1998 to that in 2002?
Make the answer very short. 1. What is the ratio of the Area (in %) in Nicaragua in 1998 to that in 2002?
Provide a succinct answer. 0.8. What is the ratio of the Area (in %) in Australia in 1998 to that in 2003?
Your answer should be very brief. 0.8. What is the ratio of the Area (in %) in Nicaragua in 1998 to that in 2003?
Offer a very short reply. 0.8. What is the ratio of the Area (in %) of Australia in 1998 to that in 2004?
Provide a succinct answer. 0.8. What is the ratio of the Area (in %) of Nicaragua in 1998 to that in 2004?
Make the answer very short. 0.8. What is the ratio of the Area (in %) in Australia in 1998 to that in 2005?
Make the answer very short. 0.8. What is the ratio of the Area (in %) in Monaco in 1998 to that in 2005?
Offer a very short reply. 1. What is the ratio of the Area (in %) in Nicaragua in 1998 to that in 2005?
Offer a terse response. 0.8. What is the ratio of the Area (in %) in Virgin Islands in 1998 to that in 2005?
Make the answer very short. 1. What is the ratio of the Area (in %) in Australia in 1999 to that in 2000?
Your answer should be compact. 0.93. What is the ratio of the Area (in %) in Monaco in 1999 to that in 2000?
Provide a short and direct response. 1. What is the ratio of the Area (in %) of Nicaragua in 1999 to that in 2000?
Give a very brief answer. 1.2. What is the ratio of the Area (in %) of Virgin Islands in 1999 to that in 2000?
Your answer should be compact. 0.99. What is the ratio of the Area (in %) of Australia in 1999 to that in 2001?
Offer a terse response. 0.95. What is the ratio of the Area (in %) of Virgin Islands in 1999 to that in 2001?
Your answer should be compact. 1. What is the ratio of the Area (in %) in Australia in 1999 to that in 2002?
Your response must be concise. 0.82. What is the ratio of the Area (in %) of Monaco in 1999 to that in 2002?
Ensure brevity in your answer.  1. What is the ratio of the Area (in %) in Nicaragua in 1999 to that in 2002?
Provide a short and direct response. 1. What is the ratio of the Area (in %) in Australia in 1999 to that in 2003?
Make the answer very short. 0.82. What is the ratio of the Area (in %) in Nicaragua in 1999 to that in 2003?
Provide a succinct answer. 1. What is the ratio of the Area (in %) of Virgin Islands in 1999 to that in 2003?
Make the answer very short. 1. What is the ratio of the Area (in %) in Australia in 1999 to that in 2004?
Offer a terse response. 0.81. What is the ratio of the Area (in %) of Nicaragua in 1999 to that in 2004?
Your answer should be very brief. 1. What is the ratio of the Area (in %) in Virgin Islands in 1999 to that in 2004?
Offer a very short reply. 1. What is the ratio of the Area (in %) in Australia in 1999 to that in 2005?
Your answer should be very brief. 0.81. What is the ratio of the Area (in %) in Monaco in 1999 to that in 2005?
Give a very brief answer. 1. What is the ratio of the Area (in %) in Virgin Islands in 1999 to that in 2005?
Make the answer very short. 1. What is the ratio of the Area (in %) in Australia in 2000 to that in 2001?
Your answer should be very brief. 1.02. What is the ratio of the Area (in %) of Monaco in 2000 to that in 2001?
Provide a short and direct response. 1. What is the ratio of the Area (in %) in Nicaragua in 2000 to that in 2001?
Your response must be concise. 0.83. What is the ratio of the Area (in %) in Virgin Islands in 2000 to that in 2001?
Make the answer very short. 1.01. What is the ratio of the Area (in %) of Australia in 2000 to that in 2002?
Ensure brevity in your answer.  0.88. What is the ratio of the Area (in %) of Monaco in 2000 to that in 2002?
Ensure brevity in your answer.  1. What is the ratio of the Area (in %) in Nicaragua in 2000 to that in 2002?
Make the answer very short. 0.83. What is the ratio of the Area (in %) of Virgin Islands in 2000 to that in 2002?
Give a very brief answer. 1.01. What is the ratio of the Area (in %) in Australia in 2000 to that in 2003?
Make the answer very short. 0.88. What is the ratio of the Area (in %) in Monaco in 2000 to that in 2003?
Provide a succinct answer. 1. What is the ratio of the Area (in %) in Nicaragua in 2000 to that in 2003?
Provide a succinct answer. 0.83. What is the ratio of the Area (in %) in Virgin Islands in 2000 to that in 2003?
Make the answer very short. 1.01. What is the ratio of the Area (in %) in Australia in 2000 to that in 2004?
Your response must be concise. 0.88. What is the ratio of the Area (in %) of Nicaragua in 2000 to that in 2004?
Offer a very short reply. 0.83. What is the ratio of the Area (in %) of Virgin Islands in 2000 to that in 2004?
Provide a succinct answer. 1.01. What is the ratio of the Area (in %) of Australia in 2000 to that in 2005?
Provide a short and direct response. 0.88. What is the ratio of the Area (in %) of Monaco in 2000 to that in 2005?
Make the answer very short. 1. What is the ratio of the Area (in %) in Nicaragua in 2000 to that in 2005?
Provide a short and direct response. 0.83. What is the ratio of the Area (in %) of Virgin Islands in 2000 to that in 2005?
Ensure brevity in your answer.  1.01. What is the ratio of the Area (in %) of Australia in 2001 to that in 2002?
Your response must be concise. 0.86. What is the ratio of the Area (in %) of Monaco in 2001 to that in 2002?
Your response must be concise. 1. What is the ratio of the Area (in %) of Virgin Islands in 2001 to that in 2002?
Your answer should be very brief. 1. What is the ratio of the Area (in %) of Australia in 2001 to that in 2003?
Offer a terse response. 0.86. What is the ratio of the Area (in %) in Monaco in 2001 to that in 2003?
Keep it short and to the point. 1. What is the ratio of the Area (in %) in Virgin Islands in 2001 to that in 2003?
Offer a terse response. 1. What is the ratio of the Area (in %) in Australia in 2001 to that in 2004?
Provide a succinct answer. 0.86. What is the ratio of the Area (in %) in Monaco in 2001 to that in 2004?
Provide a short and direct response. 1. What is the ratio of the Area (in %) of Nicaragua in 2001 to that in 2004?
Your response must be concise. 1. What is the ratio of the Area (in %) in Virgin Islands in 2001 to that in 2004?
Offer a terse response. 1. What is the ratio of the Area (in %) in Australia in 2001 to that in 2005?
Give a very brief answer. 0.86. What is the ratio of the Area (in %) of Nicaragua in 2001 to that in 2005?
Your answer should be very brief. 1. What is the ratio of the Area (in %) in Virgin Islands in 2001 to that in 2005?
Give a very brief answer. 1. What is the ratio of the Area (in %) in Australia in 2002 to that in 2003?
Your answer should be very brief. 1. What is the ratio of the Area (in %) in Nicaragua in 2002 to that in 2003?
Your answer should be very brief. 1. What is the ratio of the Area (in %) of Virgin Islands in 2002 to that in 2003?
Offer a very short reply. 1. What is the ratio of the Area (in %) in Monaco in 2002 to that in 2004?
Provide a succinct answer. 1. What is the ratio of the Area (in %) of Australia in 2002 to that in 2005?
Your response must be concise. 0.99. What is the ratio of the Area (in %) of Monaco in 2002 to that in 2005?
Provide a succinct answer. 1. What is the ratio of the Area (in %) in Nicaragua in 2002 to that in 2005?
Keep it short and to the point. 1. What is the ratio of the Area (in %) of Virgin Islands in 2002 to that in 2005?
Keep it short and to the point. 1. What is the ratio of the Area (in %) of Australia in 2003 to that in 2004?
Provide a succinct answer. 1. What is the ratio of the Area (in %) of Nicaragua in 2003 to that in 2004?
Your response must be concise. 1. What is the ratio of the Area (in %) of Nicaragua in 2003 to that in 2005?
Make the answer very short. 1. What is the ratio of the Area (in %) in Virgin Islands in 2003 to that in 2005?
Offer a very short reply. 1. What is the ratio of the Area (in %) of Monaco in 2004 to that in 2005?
Your answer should be compact. 1. What is the difference between the highest and the second highest Area (in %) of Australia?
Provide a short and direct response. 0.05. What is the difference between the highest and the second highest Area (in %) of Monaco?
Make the answer very short. 0.01. What is the difference between the highest and the second highest Area (in %) of Virgin Islands?
Offer a terse response. 0.12. What is the difference between the highest and the lowest Area (in %) of Australia?
Provide a succinct answer. 2.1. What is the difference between the highest and the lowest Area (in %) of Monaco?
Offer a terse response. 0.01. What is the difference between the highest and the lowest Area (in %) of Nicaragua?
Provide a succinct answer. 7.45. What is the difference between the highest and the lowest Area (in %) of Virgin Islands?
Offer a very short reply. 0.12. 